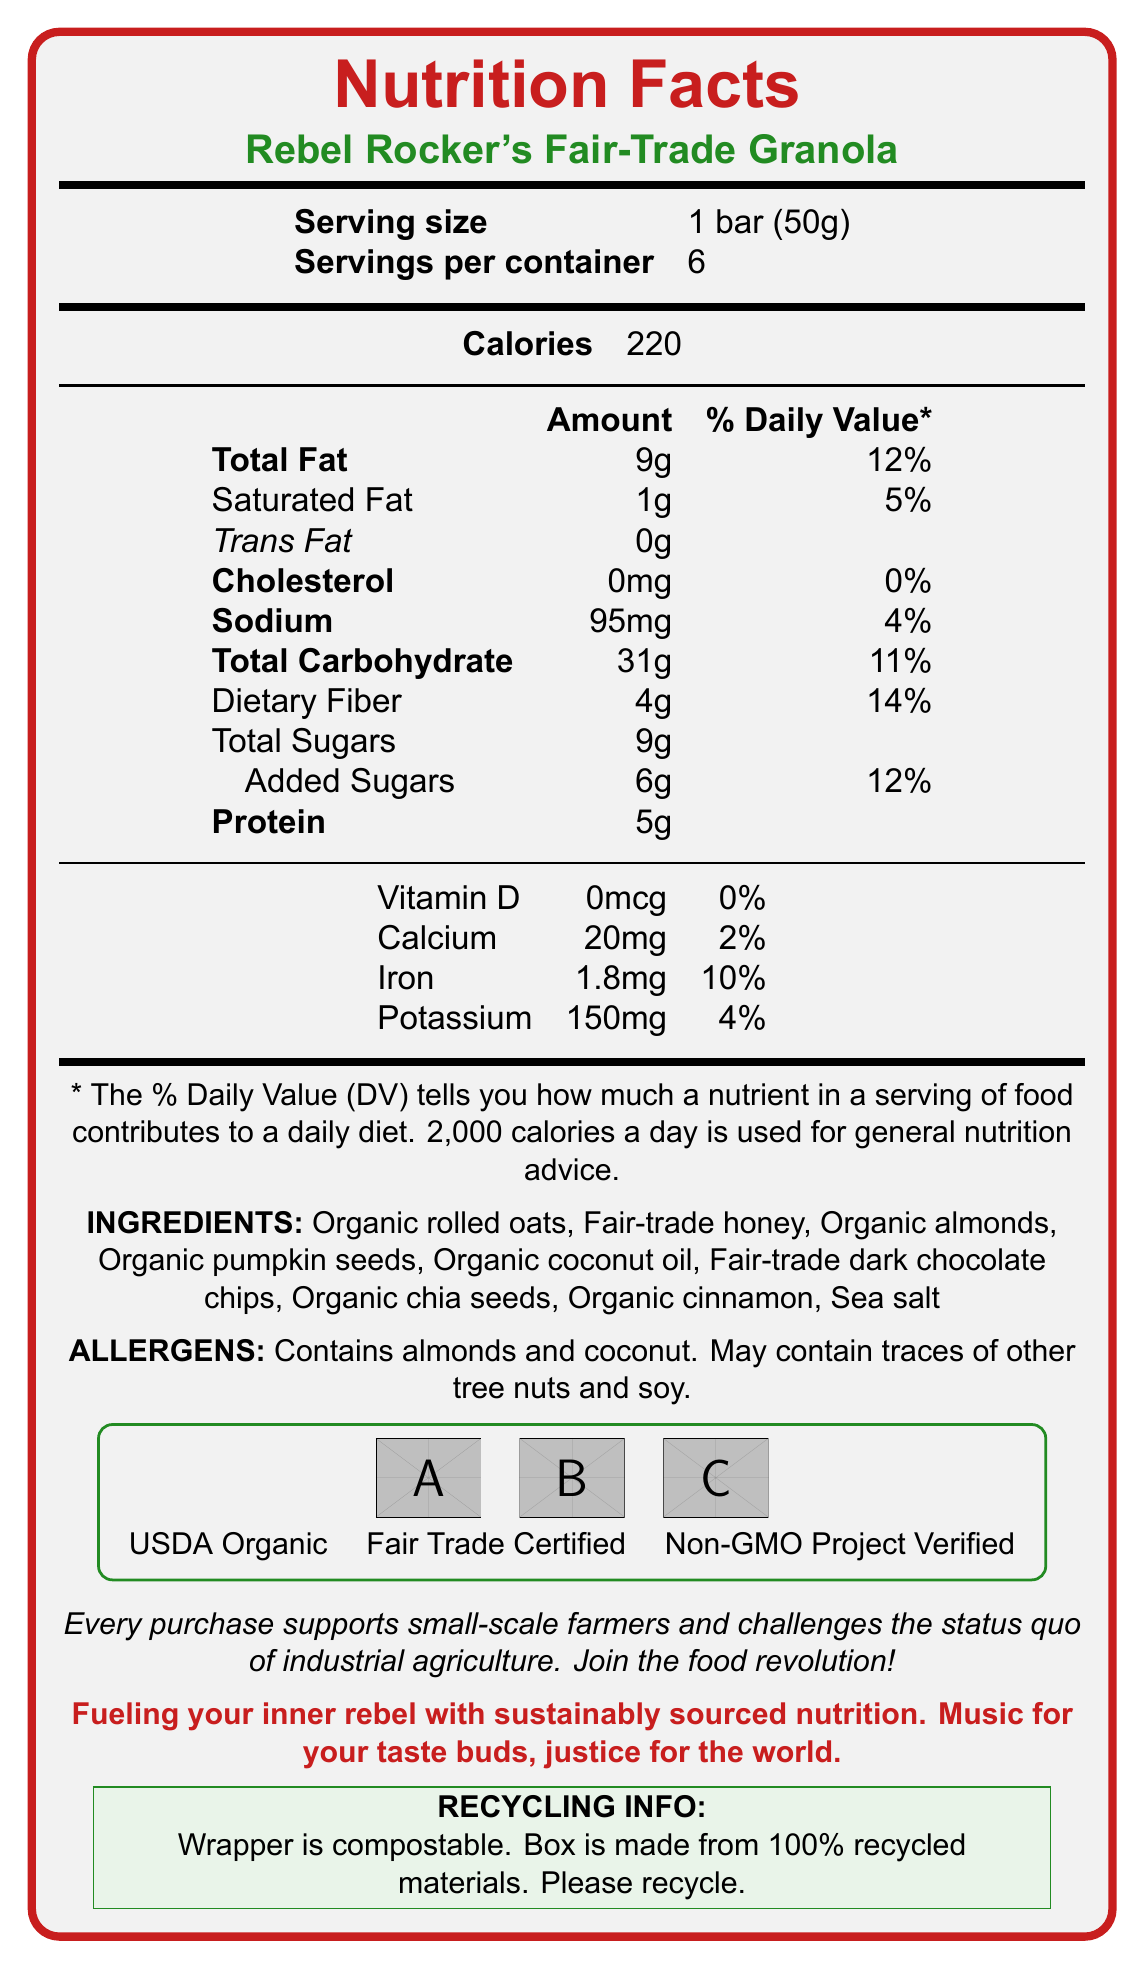What is the serving size for Rebel Rocker's Fair-Trade Granola? The serving size is listed as "1 bar (50g)" at the top of the Nutrition Facts panel.
Answer: 1 bar (50g) How many calories are in one serving of Rebel Rocker's Fair-Trade Granola? The document states that one serving contains 220 calories.
Answer: 220 What is the percentage of daily value for total fat in one serving? The document lists 9g of total fat, which corresponds to 12% of the daily value.
Answer: 12% Which ingredient is listed first in the ingredients section? The first ingredient mentioned in the list is "Organic rolled oats".
Answer: Organic rolled oats Does the product contain any trans fats? The document clearly shows that the trans fat content is 0g.
Answer: No How much protein is in one serving of the granola bar? The protein content per serving is listed as 5g.
Answer: 5g Does this product contain any ingredients that might cause allergies? The document lists "Contains almonds and coconut. May contain traces of other tree nuts and soy."
Answer: Yes What are the certifications displayed on the packaging? A. USDA Organic, B. Fair Trade Certified, C. Non-GMO Project Verified, D. All of the above The document features icons for USDA Organic, Fair Trade Certified, and Non-GMO Project Verified, indicating all certifications apply.
Answer: D. All of the above Which nutrient has the highest percentage of daily value per serving in this granola bar? A. Iron, B. Calcium, C. Dietary Fiber, D. Sodium Dietary fiber is listed with a 14% daily value, which is higher than the rest of the nutrients mentioned.
Answer: C. Dietary Fiber Is the wrapper of the granola bar recyclable? The document specifically states that the wrapper is compostable, not recyclable.
Answer: No Summarize the overall message and purpose of this document. The main idea centers on informing the consumers about the nutritional content, socially responsible sourcing, and eco-friendly packaging of the granola bar, aiming to attract ethically-minded customers.
Answer: The document provides comprehensive nutritional information for Rebel Rocker's Fair-Trade Granola, emphasizing its organic and fair-trade certifications. It highlights the product's role in supporting small-scale farmers against the backdrop of industrial agriculture, promoting sustainability and social responsibility. What is the country of origin for the ingredients used in the granola bar? The document does not provide information about the country of origin for the ingredients used in the granola bar.
Answer: Cannot be determined 